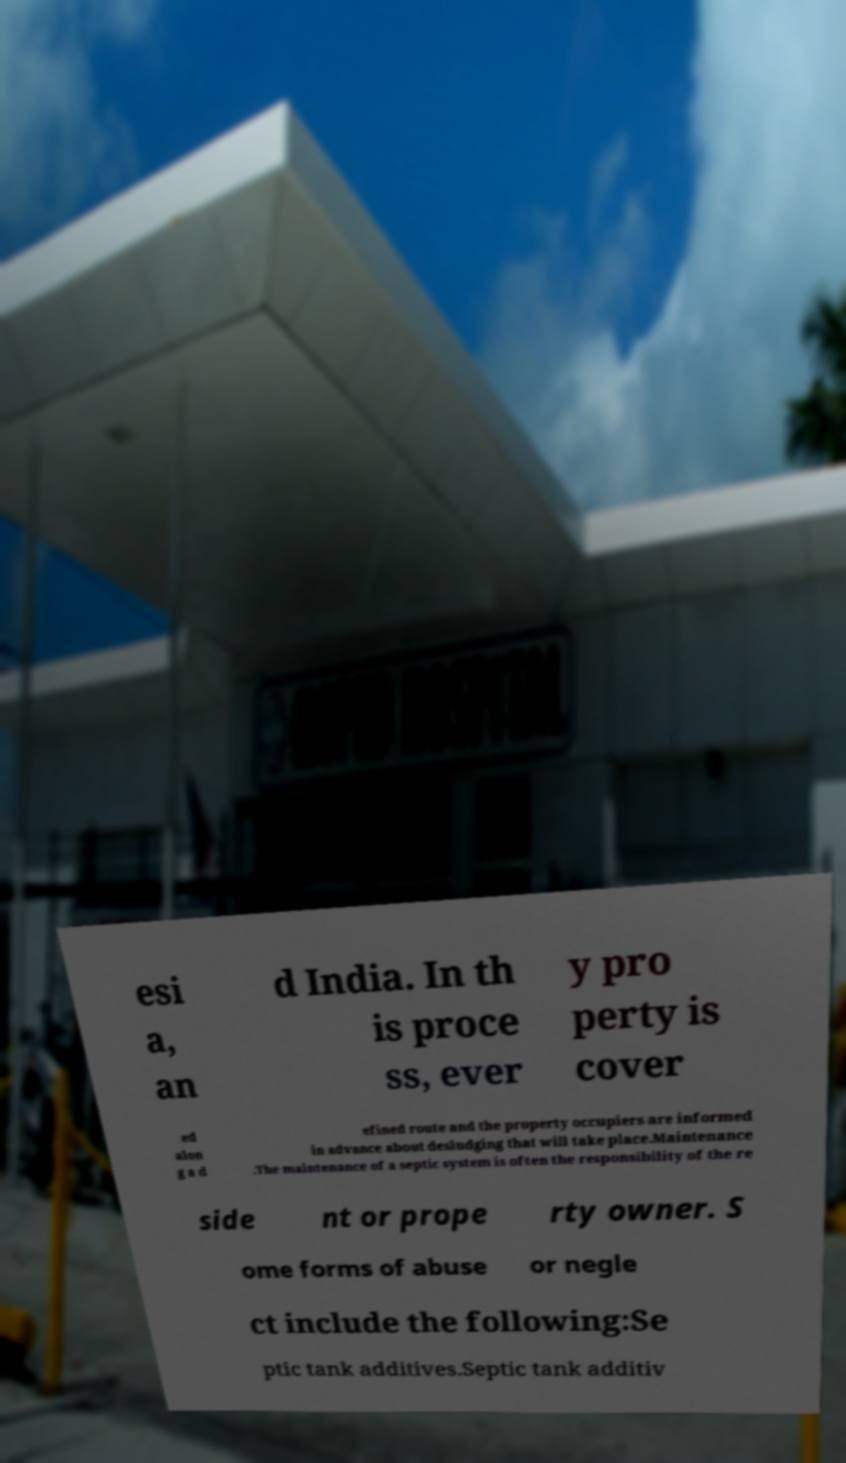Could you extract and type out the text from this image? esi a, an d India. In th is proce ss, ever y pro perty is cover ed alon g a d efined route and the property occupiers are informed in advance about desludging that will take place.Maintenance .The maintenance of a septic system is often the responsibility of the re side nt or prope rty owner. S ome forms of abuse or negle ct include the following:Se ptic tank additives.Septic tank additiv 